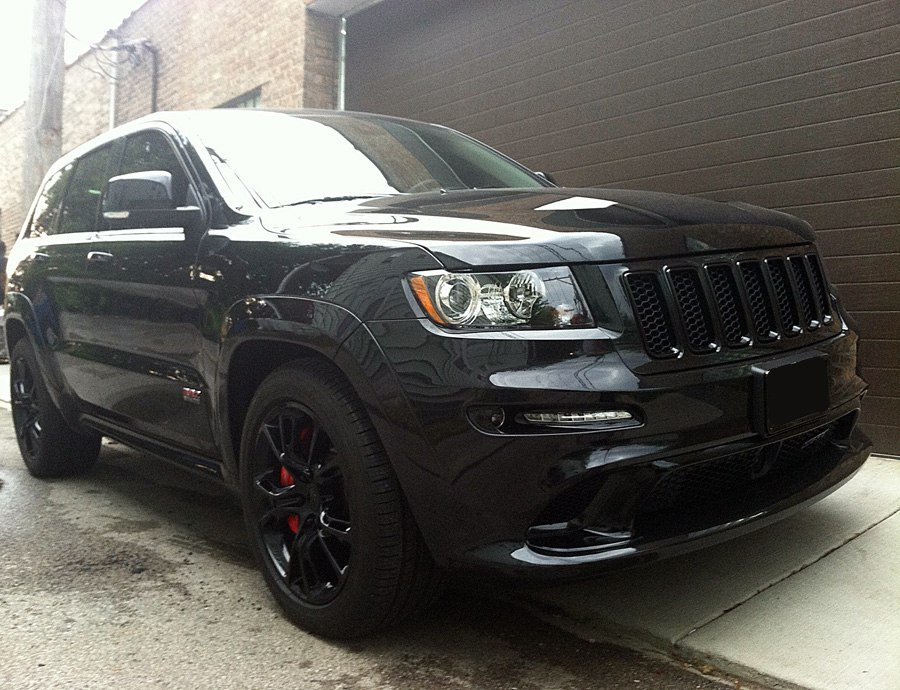Considering the style of the wheels and the brake calipers, what might be the performance characteristics of this SUV? The large black wheels with a sleek five-spoke design, combined with eye-catching red brake calipers, suggest that this SUV is engineered with performance capabilities in mind. The presence of low-profile tires indicates a preference for superior handling and enhanced grip on paved surfaces, rather than prioritizing off-road adventures. The stylish red brake calipers often hint at an upgraded, high-performance braking system that can efficiently manage higher speeds and ensure better stopping power. These visual elements collectively imply that the SUV is tuned for a sportier driving experience, potentially featuring a powerful engine and a refined, responsive suspension system, distinguishing it from standard models. 